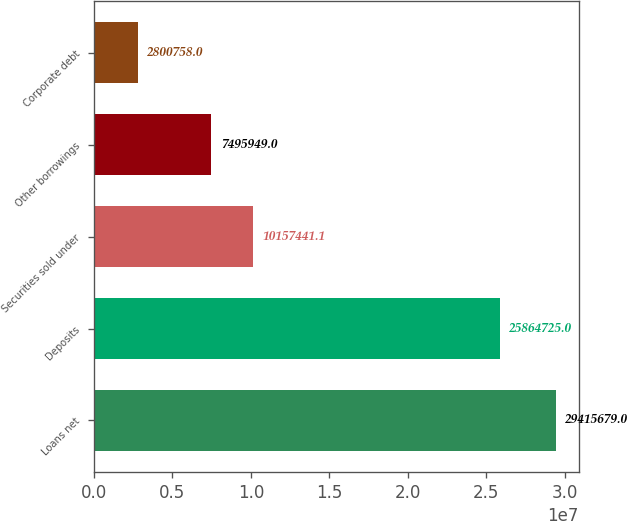Convert chart. <chart><loc_0><loc_0><loc_500><loc_500><bar_chart><fcel>Loans net<fcel>Deposits<fcel>Securities sold under<fcel>Other borrowings<fcel>Corporate debt<nl><fcel>2.94157e+07<fcel>2.58647e+07<fcel>1.01574e+07<fcel>7.49595e+06<fcel>2.80076e+06<nl></chart> 